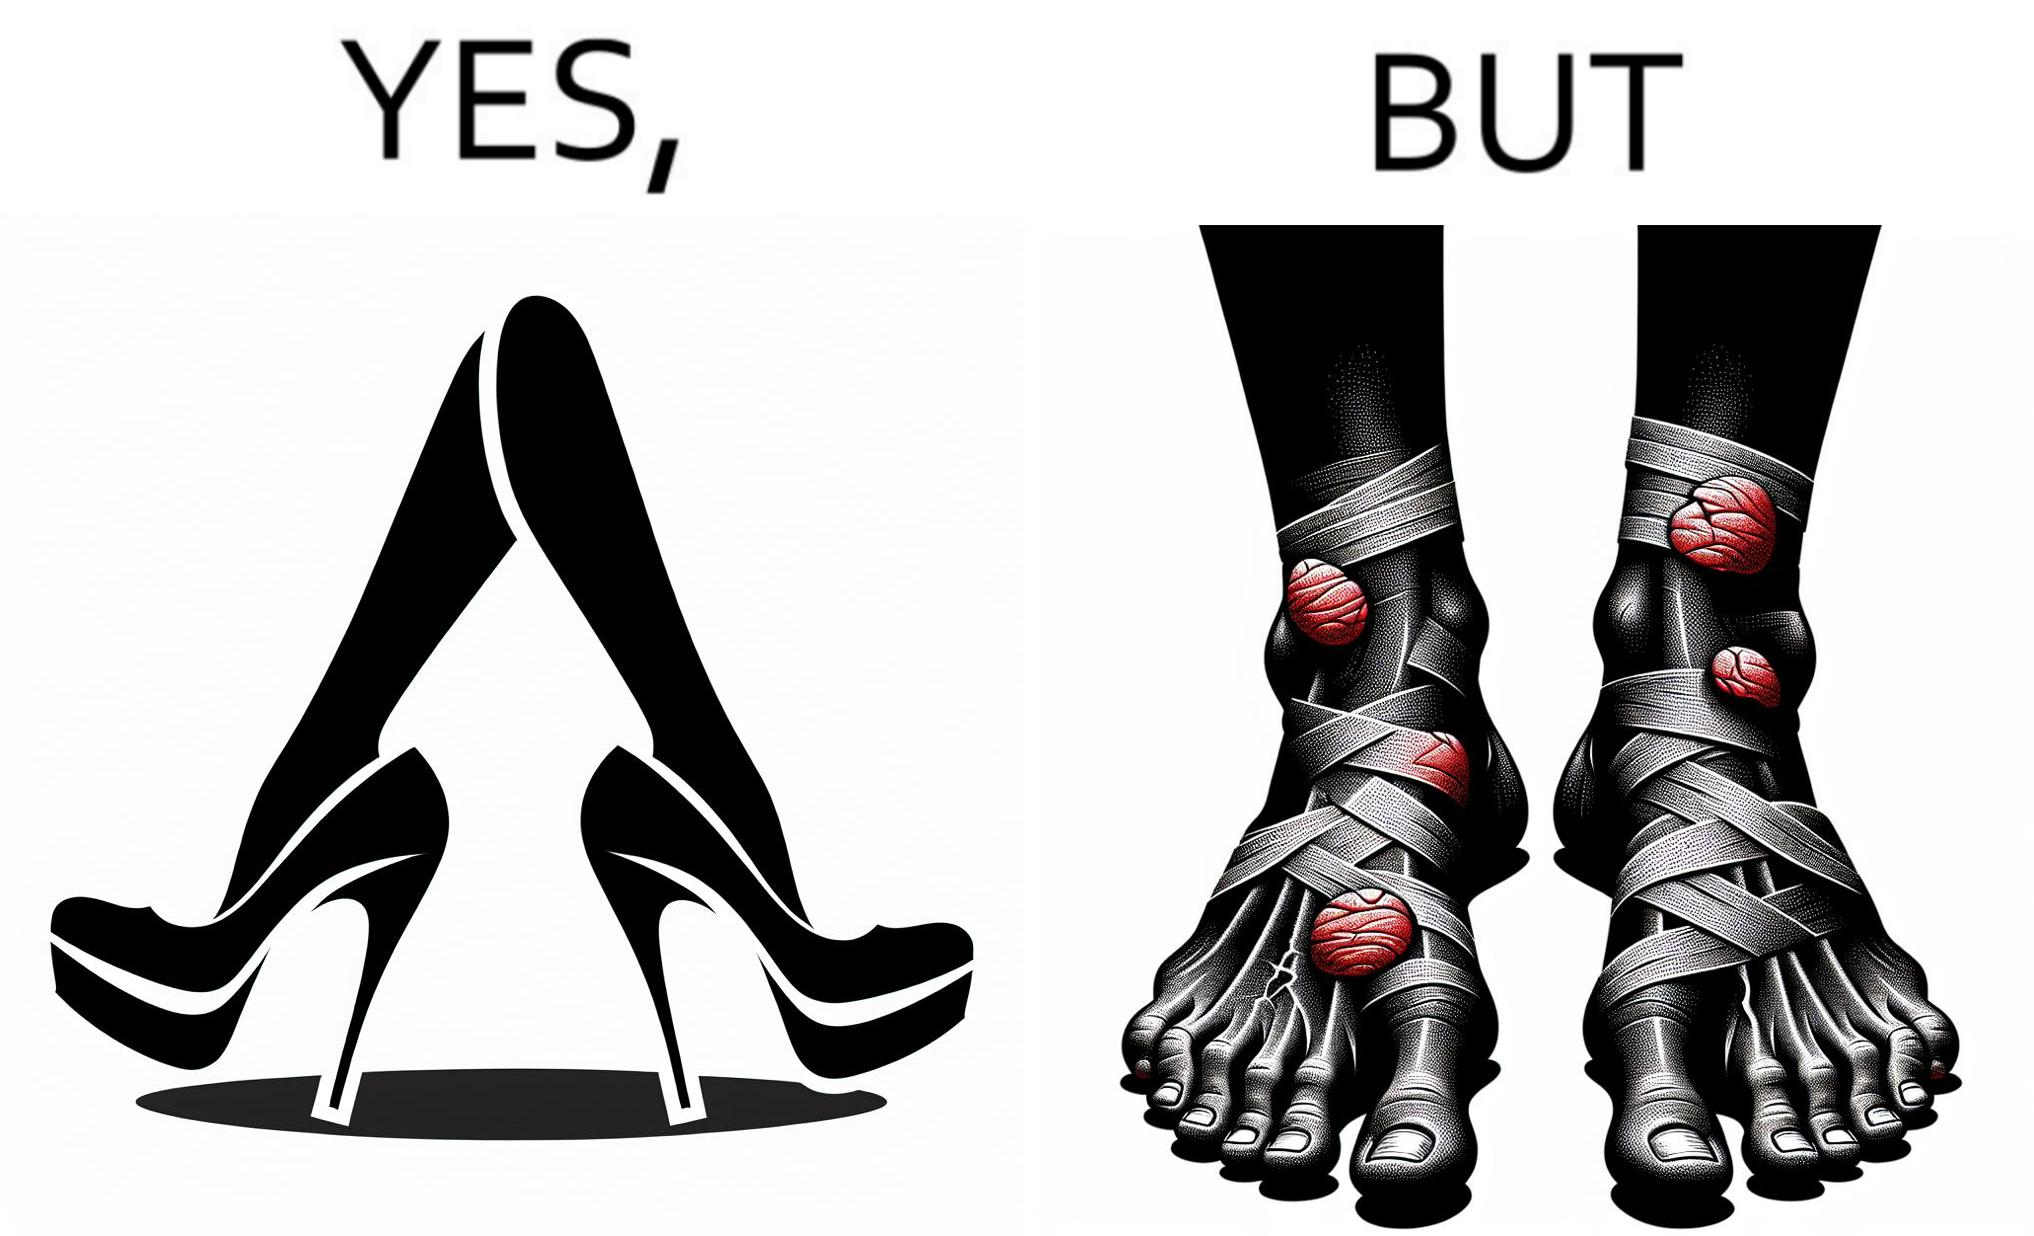Explain the humor or irony in this image. The images are funny since they show how the prettiest footwears like high heels, end up causing a lot of physical discomfort to the user, all in the name fashion 